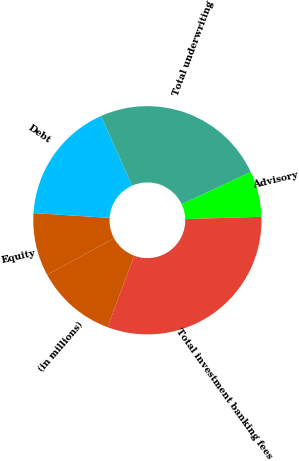Convert chart to OTSL. <chart><loc_0><loc_0><loc_500><loc_500><pie_chart><fcel>(in millions)<fcel>Equity<fcel>Debt<fcel>Total underwriting<fcel>Advisory<fcel>Total investment banking fees<nl><fcel>11.4%<fcel>8.93%<fcel>17.35%<fcel>24.7%<fcel>6.46%<fcel>31.16%<nl></chart> 